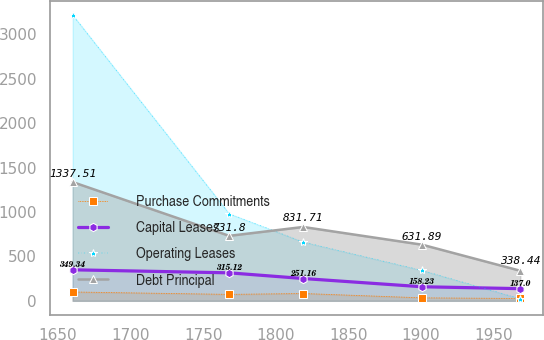Convert chart to OTSL. <chart><loc_0><loc_0><loc_500><loc_500><line_chart><ecel><fcel>Purchase Commitments<fcel>Capital Leases<fcel>Operating Leases<fcel>Debt Principal<nl><fcel>1660.17<fcel>99.45<fcel>349.34<fcel>3219.44<fcel>1337.51<nl><fcel>1767.92<fcel>72.37<fcel>315.12<fcel>982<fcel>731.8<nl><fcel>1818.89<fcel>82.32<fcel>251.16<fcel>662.36<fcel>831.71<nl><fcel>1900.75<fcel>33.44<fcel>158.23<fcel>342.72<fcel>631.89<nl><fcel>1968.31<fcel>26.1<fcel>137<fcel>23.08<fcel>338.44<nl></chart> 